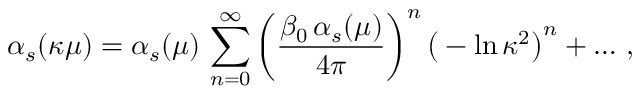<formula> <loc_0><loc_0><loc_500><loc_500>\alpha _ { s } ( \kappa \mu ) = \alpha _ { s } ( \mu ) \, \sum _ { n = 0 } ^ { \infty } \left ( { \frac { \beta _ { 0 } \, \alpha _ { s } ( \mu ) } { 4 \pi } } \right ) ^ { n } \, \left ( - \ln \kappa ^ { 2 } \right ) ^ { n } + \dots \, ,</formula> 